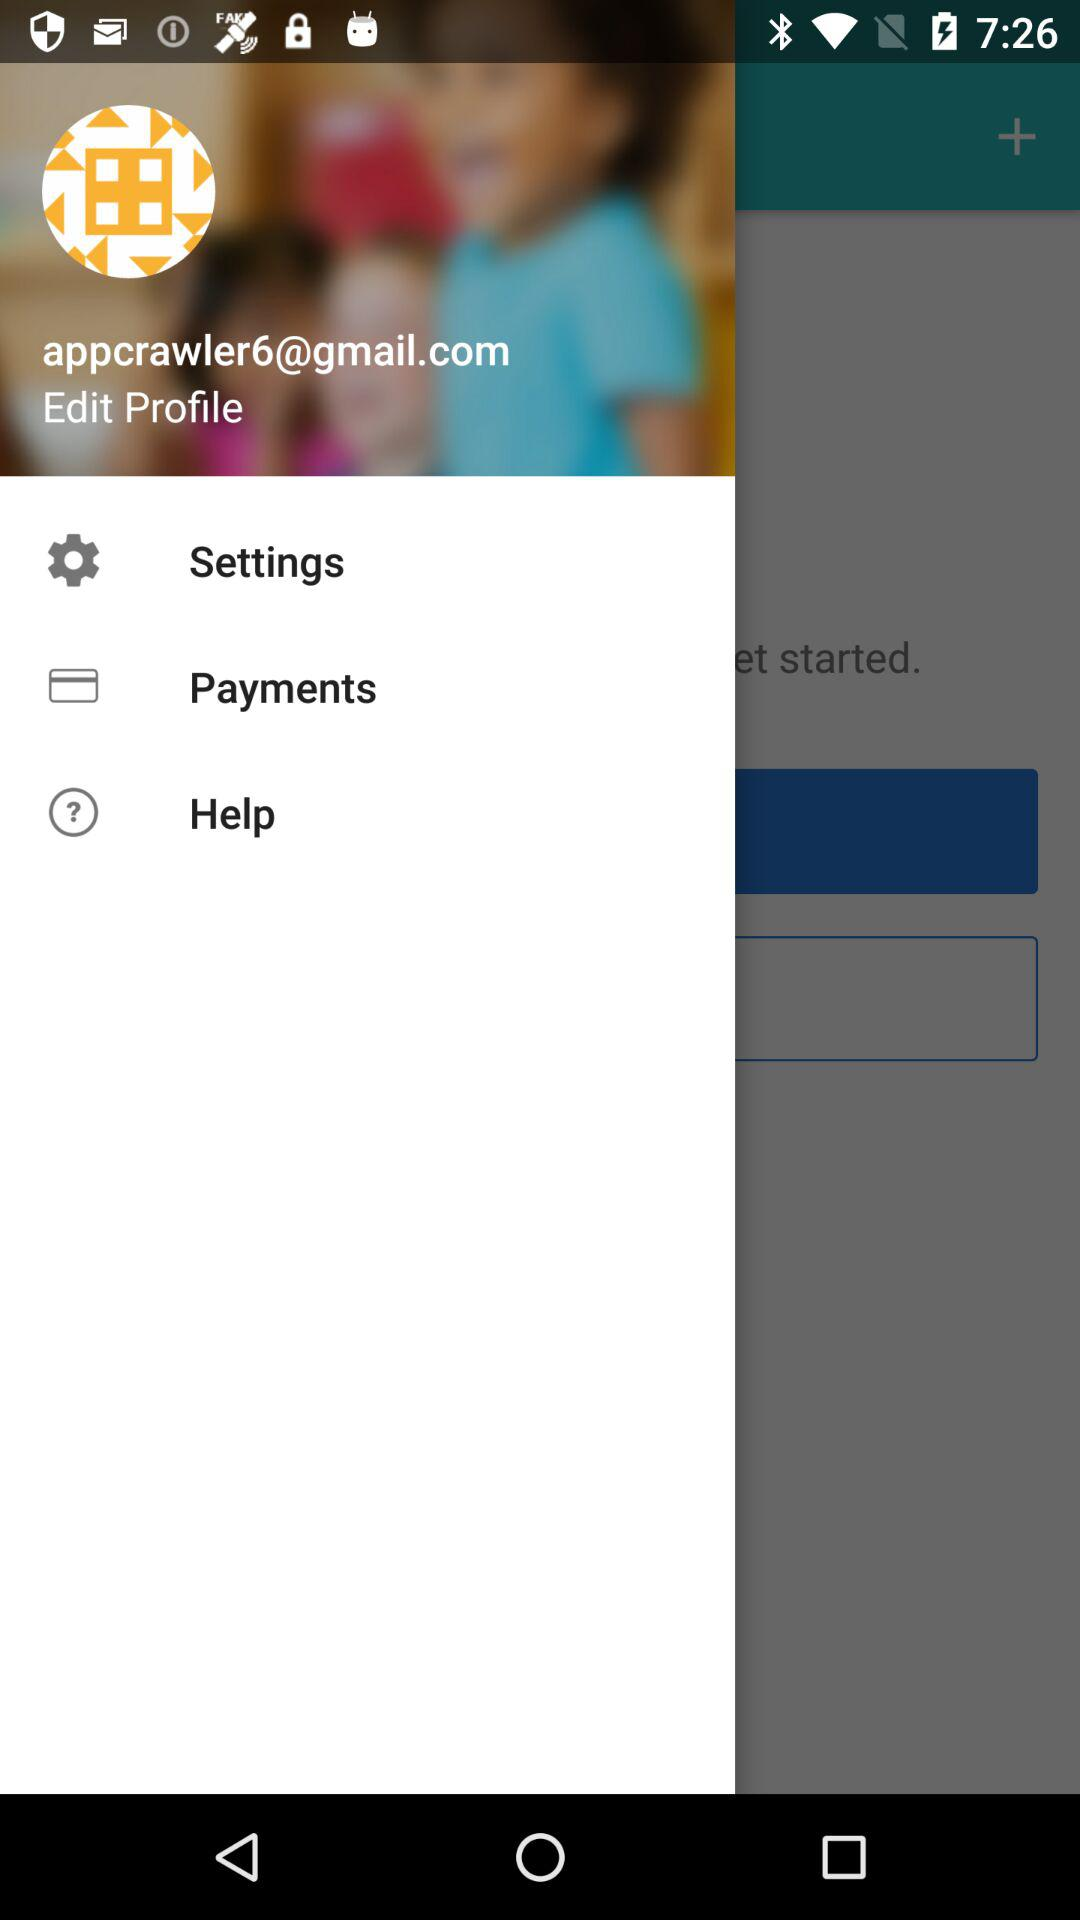How many payments does the user have to make?
When the provided information is insufficient, respond with <no answer>. <no answer> 